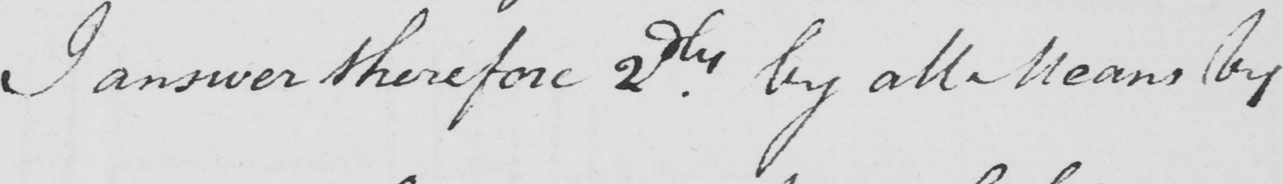What does this handwritten line say? I answer therefore 2dly by all Means by 